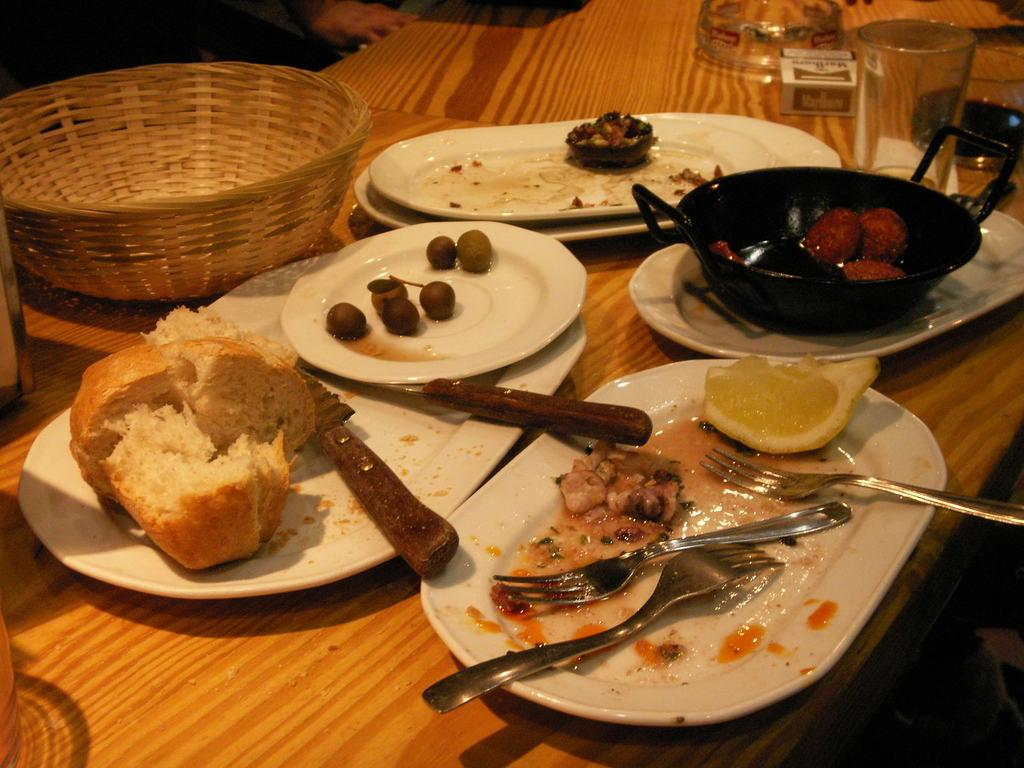What type of food can be seen in the image? There is food in the image, including bread. What utensils are present in the image? A knife and fork are present in the image. How is the bread arranged in the image? The bread is on a white plate. How many white plates are visible in the image? There are multiple white plates in the image. Where are the plates placed? The plates are placed on a table top. What can be seen on the left side of the table? There is a wooden basket on the left side of the table. Can you tell me how many trains are visible in the image? There are no trains present in the image. What type of monkey is sitting on the table in the image? There is no monkey present in the image. 